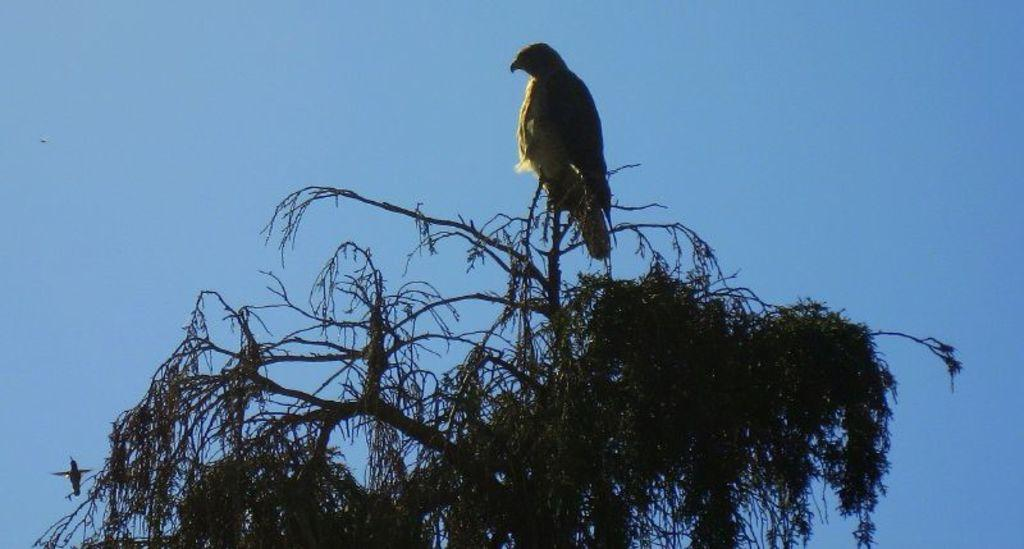What type of animals can be seen in the picture? Birds can be seen in the picture. What is the main object in the picture? There is a tree in the picture. What can be seen in the background of the picture? The sky is visible in the background of the picture. How many bricks are visible in the picture? There are no bricks present in the picture; it features birds and a tree. Can you tell me how many boys are helping the birds in the picture? There are no boys present in the picture, nor are they helping the birds. 